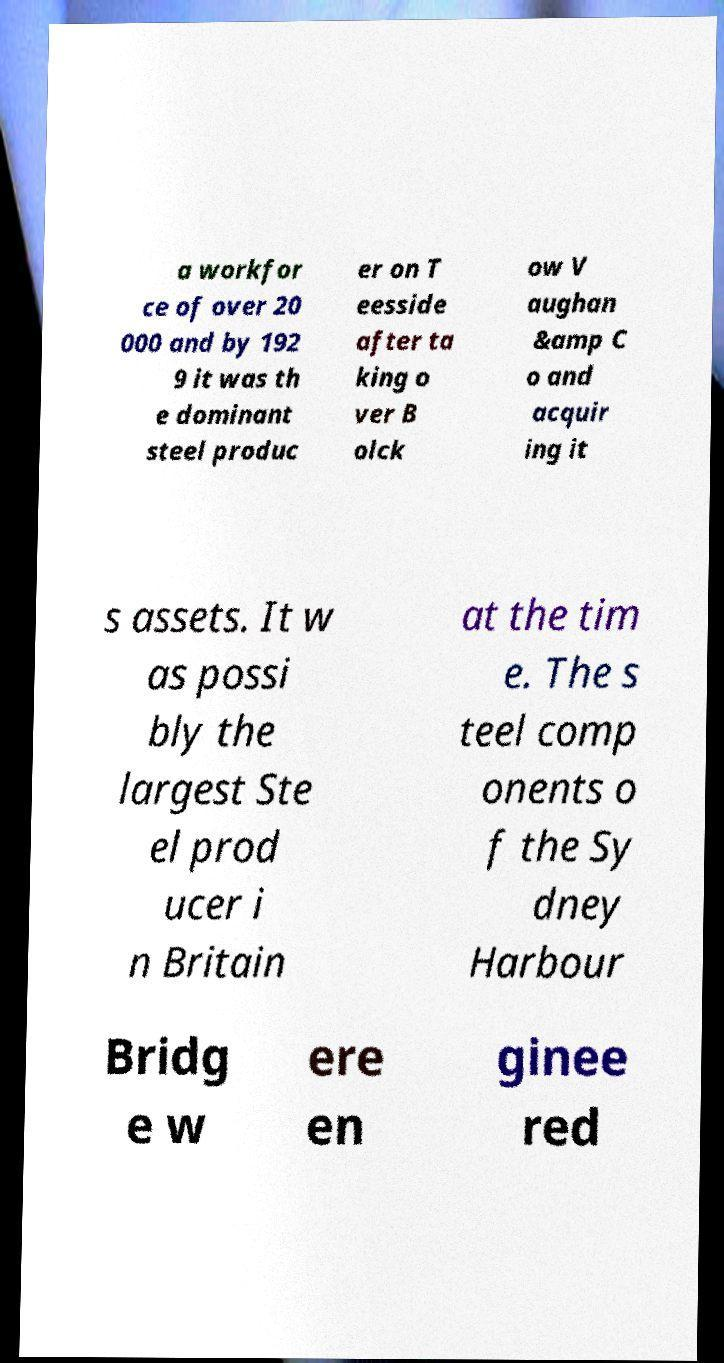Can you read and provide the text displayed in the image?This photo seems to have some interesting text. Can you extract and type it out for me? a workfor ce of over 20 000 and by 192 9 it was th e dominant steel produc er on T eesside after ta king o ver B olck ow V aughan &amp C o and acquir ing it s assets. It w as possi bly the largest Ste el prod ucer i n Britain at the tim e. The s teel comp onents o f the Sy dney Harbour Bridg e w ere en ginee red 